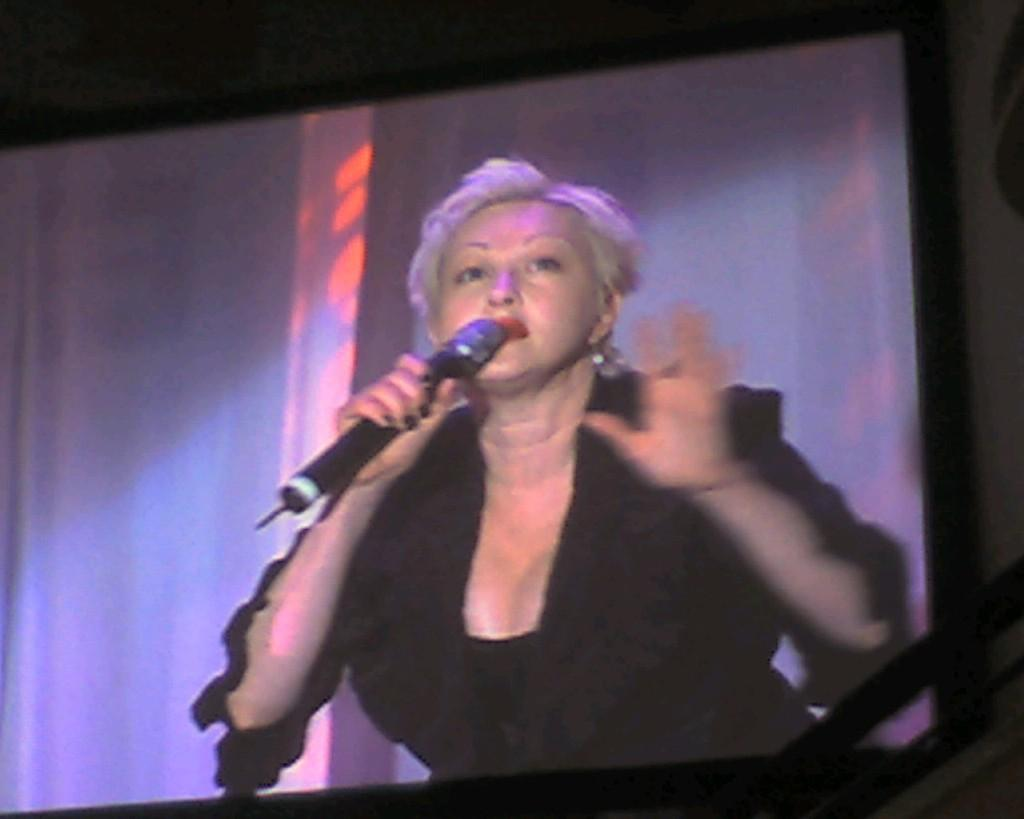What is the main subject of the image? There is a photo of a woman in the image. What is the woman wearing in the photo? The woman is wearing a black dress in the photo. What object is the woman holding in the photo? The woman is holding a microphone in her hand in the photo. How is the photo of the woman displayed in the image? The photo is displayed on a screen. What type of land can be seen in the background of the photo? There is no land visible in the photo, as it is a close-up image of a woman holding a microphone. How many girls are present in the photo? There is only one woman present in the photo, not a group of girls. 